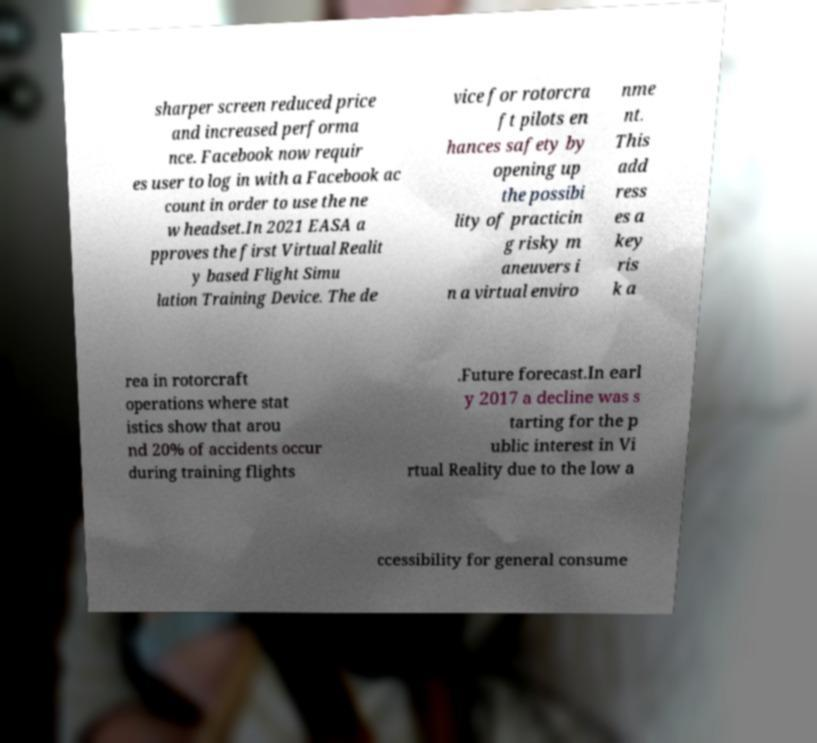Could you extract and type out the text from this image? sharper screen reduced price and increased performa nce. Facebook now requir es user to log in with a Facebook ac count in order to use the ne w headset.In 2021 EASA a pproves the first Virtual Realit y based Flight Simu lation Training Device. The de vice for rotorcra ft pilots en hances safety by opening up the possibi lity of practicin g risky m aneuvers i n a virtual enviro nme nt. This add ress es a key ris k a rea in rotorcraft operations where stat istics show that arou nd 20% of accidents occur during training flights .Future forecast.In earl y 2017 a decline was s tarting for the p ublic interest in Vi rtual Reality due to the low a ccessibility for general consume 